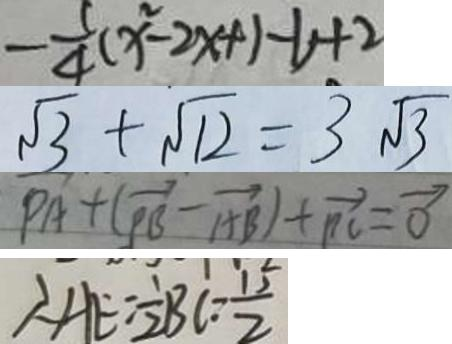Convert formula to latex. <formula><loc_0><loc_0><loc_500><loc_500>- \frac { 5 } { 4 } ( x ^ { 2 } - 2 x + 1 - 1 ) + 2 
 \sqrt { 3 } + \sqrt { 1 2 } = 3 \sqrt { 3 } 
 P A + ( \overrightarrow { P B } - \overrightarrow { A B } ) + \overrightarrow { P C } = \overrightarrow { 0 } 
 \therefore A E = \frac { 1 } { 2 } B C = \frac { 1 5 } { 2 }</formula> 